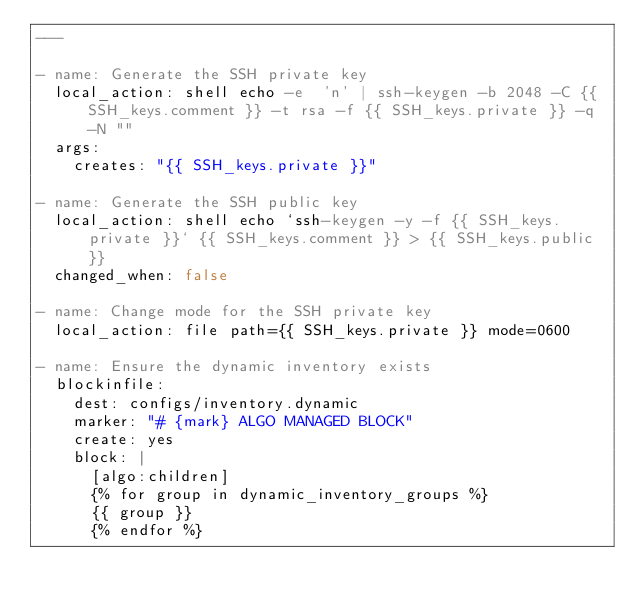<code> <loc_0><loc_0><loc_500><loc_500><_YAML_>---

- name: Generate the SSH private key
  local_action: shell echo -e  'n' | ssh-keygen -b 2048 -C {{ SSH_keys.comment }} -t rsa -f {{ SSH_keys.private }} -q -N ""
  args:
    creates: "{{ SSH_keys.private }}"

- name: Generate the SSH public key
  local_action: shell echo `ssh-keygen -y -f {{ SSH_keys.private }}` {{ SSH_keys.comment }} > {{ SSH_keys.public }}
  changed_when: false

- name: Change mode for the SSH private key
  local_action: file path={{ SSH_keys.private }} mode=0600

- name: Ensure the dynamic inventory exists
  blockinfile:
    dest: configs/inventory.dynamic
    marker: "# {mark} ALGO MANAGED BLOCK"
    create: yes
    block: |
      [algo:children]
      {% for group in dynamic_inventory_groups %}
      {{ group }}
      {% endfor %}
</code> 